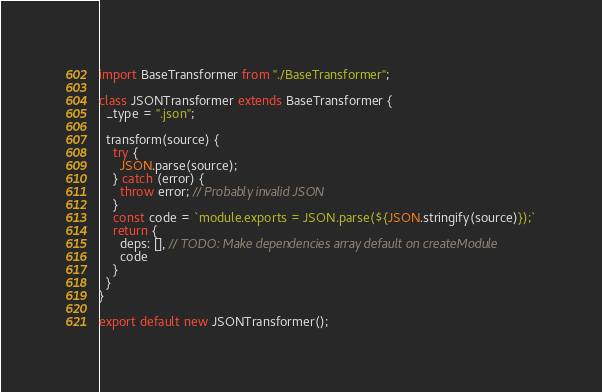Convert code to text. <code><loc_0><loc_0><loc_500><loc_500><_JavaScript_>import BaseTransformer from "./BaseTransformer";

class JSONTransformer extends BaseTransformer {
  _type = ".json";

  transform(source) {
    try {
      JSON.parse(source);
    } catch (error) {
      throw error; // Probably invalid JSON
    }
    const code = `module.exports = JSON.parse(${JSON.stringify(source)});`
    return {
      deps: [], // TODO: Make dependencies array default on createModule
      code
    }
  }
}

export default new JSONTransformer();
</code> 